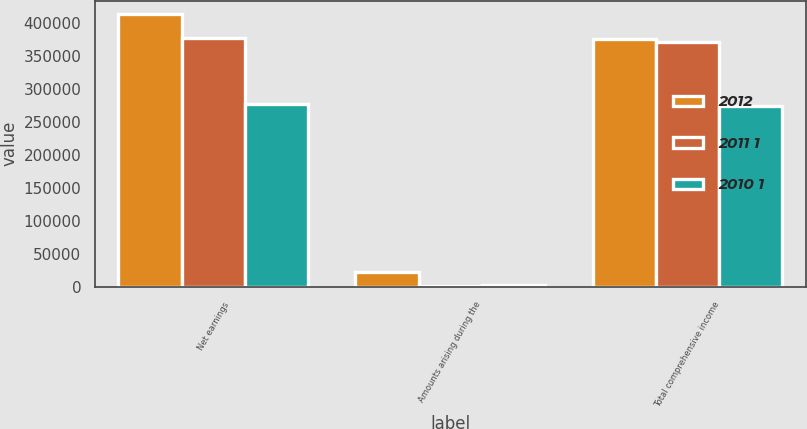Convert chart to OTSL. <chart><loc_0><loc_0><loc_500><loc_500><stacked_bar_chart><ecel><fcel>Net earnings<fcel>Amounts arising during the<fcel>Total comprehensive income<nl><fcel>2012<fcel>413795<fcel>22591<fcel>376393<nl><fcel>2011 1<fcel>377495<fcel>1828<fcel>371984<nl><fcel>2010 1<fcel>277844<fcel>2686<fcel>275158<nl></chart> 